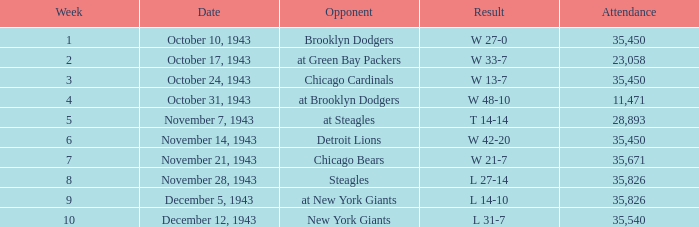What is the lowest week that has an attendance greater than 23,058, with october 24, 1943 as the date? 3.0. 